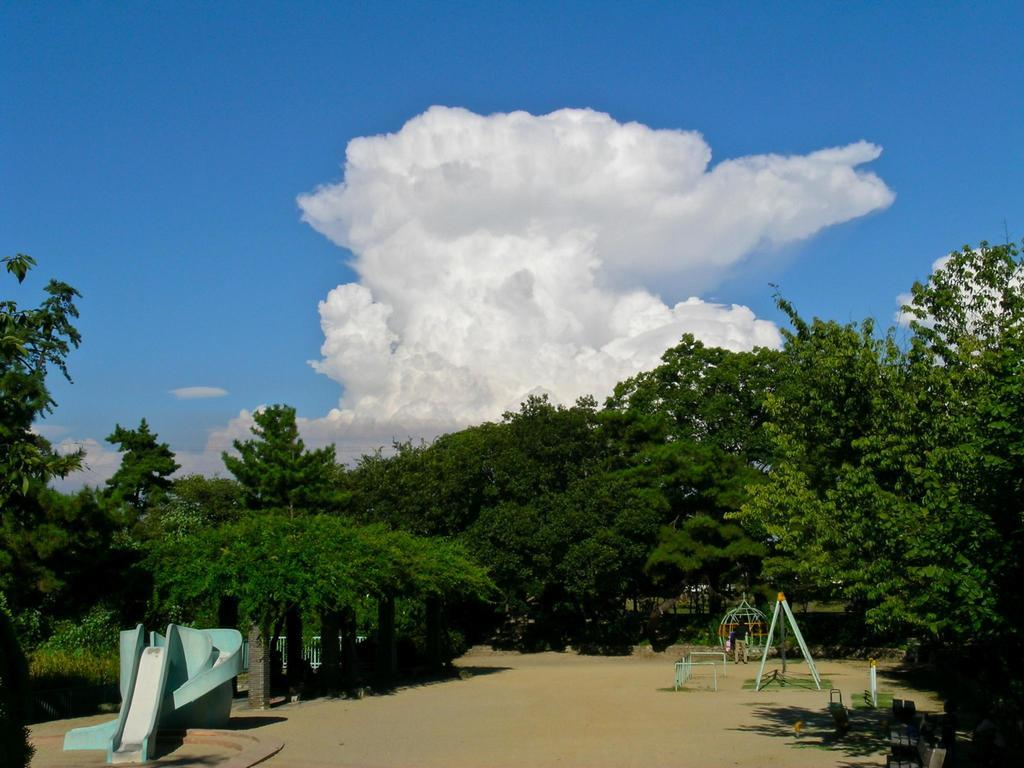What type of surface is visible in the image? There is a land in the image. What can be seen on the land? There are playing items on the land. What type of vegetation is present in the image? There are trees in the image. What is visible above the land and trees? The sky is visible in the image. Can you point out the crack in the land in the image? There is no crack visible in the land in the image. 